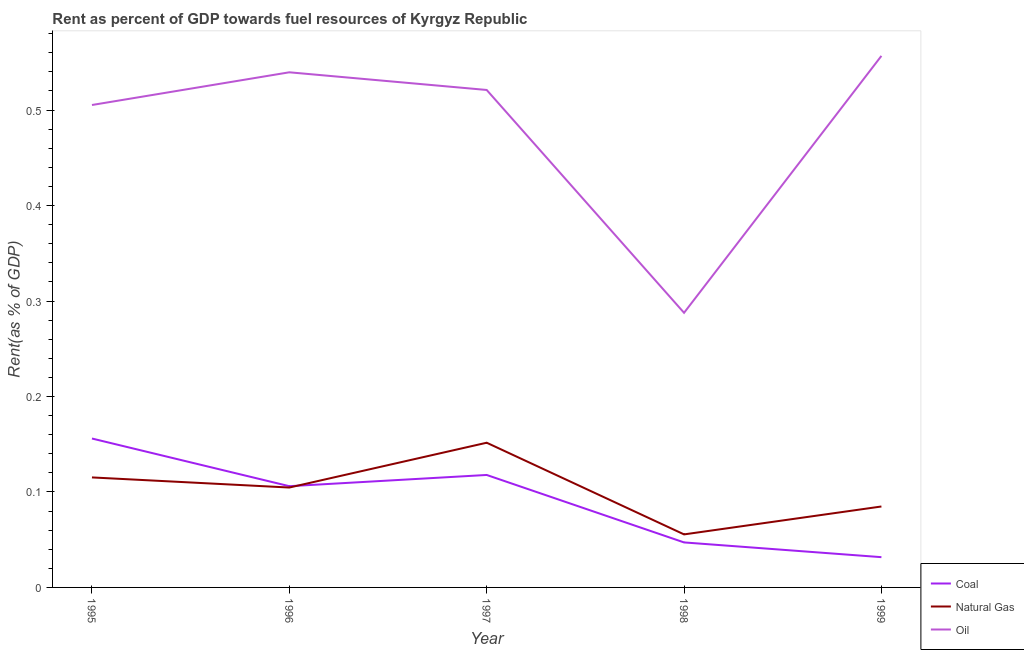How many different coloured lines are there?
Your answer should be compact. 3. What is the rent towards natural gas in 1995?
Your response must be concise. 0.12. Across all years, what is the maximum rent towards coal?
Your answer should be very brief. 0.16. Across all years, what is the minimum rent towards oil?
Keep it short and to the point. 0.29. In which year was the rent towards oil maximum?
Your answer should be very brief. 1999. What is the total rent towards natural gas in the graph?
Offer a very short reply. 0.51. What is the difference between the rent towards natural gas in 1997 and that in 1998?
Your response must be concise. 0.1. What is the difference between the rent towards oil in 1997 and the rent towards natural gas in 1999?
Provide a short and direct response. 0.44. What is the average rent towards oil per year?
Give a very brief answer. 0.48. In the year 1998, what is the difference between the rent towards coal and rent towards oil?
Keep it short and to the point. -0.24. What is the ratio of the rent towards natural gas in 1997 to that in 1999?
Give a very brief answer. 1.79. Is the rent towards coal in 1995 less than that in 1997?
Provide a succinct answer. No. Is the difference between the rent towards natural gas in 1995 and 1999 greater than the difference between the rent towards coal in 1995 and 1999?
Provide a succinct answer. No. What is the difference between the highest and the second highest rent towards natural gas?
Offer a very short reply. 0.04. What is the difference between the highest and the lowest rent towards natural gas?
Ensure brevity in your answer.  0.1. Is it the case that in every year, the sum of the rent towards coal and rent towards natural gas is greater than the rent towards oil?
Provide a succinct answer. No. Does the rent towards coal monotonically increase over the years?
Offer a very short reply. No. Is the rent towards natural gas strictly greater than the rent towards oil over the years?
Make the answer very short. No. How many lines are there?
Provide a succinct answer. 3. What is the difference between two consecutive major ticks on the Y-axis?
Your response must be concise. 0.1. Are the values on the major ticks of Y-axis written in scientific E-notation?
Your answer should be very brief. No. Does the graph contain any zero values?
Provide a short and direct response. No. Where does the legend appear in the graph?
Offer a very short reply. Bottom right. How many legend labels are there?
Make the answer very short. 3. How are the legend labels stacked?
Your answer should be very brief. Vertical. What is the title of the graph?
Provide a succinct answer. Rent as percent of GDP towards fuel resources of Kyrgyz Republic. Does "Self-employed" appear as one of the legend labels in the graph?
Keep it short and to the point. No. What is the label or title of the Y-axis?
Offer a terse response. Rent(as % of GDP). What is the Rent(as % of GDP) in Coal in 1995?
Keep it short and to the point. 0.16. What is the Rent(as % of GDP) of Natural Gas in 1995?
Ensure brevity in your answer.  0.12. What is the Rent(as % of GDP) of Oil in 1995?
Keep it short and to the point. 0.51. What is the Rent(as % of GDP) in Coal in 1996?
Provide a short and direct response. 0.11. What is the Rent(as % of GDP) in Natural Gas in 1996?
Your response must be concise. 0.1. What is the Rent(as % of GDP) of Oil in 1996?
Give a very brief answer. 0.54. What is the Rent(as % of GDP) of Coal in 1997?
Your answer should be compact. 0.12. What is the Rent(as % of GDP) of Natural Gas in 1997?
Your answer should be compact. 0.15. What is the Rent(as % of GDP) in Oil in 1997?
Offer a terse response. 0.52. What is the Rent(as % of GDP) in Coal in 1998?
Your answer should be very brief. 0.05. What is the Rent(as % of GDP) of Natural Gas in 1998?
Your response must be concise. 0.06. What is the Rent(as % of GDP) of Oil in 1998?
Your response must be concise. 0.29. What is the Rent(as % of GDP) in Coal in 1999?
Your answer should be very brief. 0.03. What is the Rent(as % of GDP) in Natural Gas in 1999?
Provide a short and direct response. 0.08. What is the Rent(as % of GDP) of Oil in 1999?
Provide a succinct answer. 0.56. Across all years, what is the maximum Rent(as % of GDP) in Coal?
Keep it short and to the point. 0.16. Across all years, what is the maximum Rent(as % of GDP) in Natural Gas?
Make the answer very short. 0.15. Across all years, what is the maximum Rent(as % of GDP) of Oil?
Your response must be concise. 0.56. Across all years, what is the minimum Rent(as % of GDP) in Coal?
Provide a short and direct response. 0.03. Across all years, what is the minimum Rent(as % of GDP) of Natural Gas?
Offer a very short reply. 0.06. Across all years, what is the minimum Rent(as % of GDP) in Oil?
Provide a succinct answer. 0.29. What is the total Rent(as % of GDP) in Coal in the graph?
Offer a terse response. 0.46. What is the total Rent(as % of GDP) in Natural Gas in the graph?
Offer a terse response. 0.51. What is the total Rent(as % of GDP) in Oil in the graph?
Your answer should be compact. 2.41. What is the difference between the Rent(as % of GDP) in Coal in 1995 and that in 1996?
Provide a succinct answer. 0.05. What is the difference between the Rent(as % of GDP) of Natural Gas in 1995 and that in 1996?
Ensure brevity in your answer.  0.01. What is the difference between the Rent(as % of GDP) in Oil in 1995 and that in 1996?
Offer a very short reply. -0.03. What is the difference between the Rent(as % of GDP) in Coal in 1995 and that in 1997?
Offer a very short reply. 0.04. What is the difference between the Rent(as % of GDP) in Natural Gas in 1995 and that in 1997?
Provide a short and direct response. -0.04. What is the difference between the Rent(as % of GDP) of Oil in 1995 and that in 1997?
Provide a short and direct response. -0.02. What is the difference between the Rent(as % of GDP) of Coal in 1995 and that in 1998?
Offer a terse response. 0.11. What is the difference between the Rent(as % of GDP) of Natural Gas in 1995 and that in 1998?
Ensure brevity in your answer.  0.06. What is the difference between the Rent(as % of GDP) in Oil in 1995 and that in 1998?
Offer a very short reply. 0.22. What is the difference between the Rent(as % of GDP) in Coal in 1995 and that in 1999?
Your answer should be compact. 0.12. What is the difference between the Rent(as % of GDP) in Natural Gas in 1995 and that in 1999?
Provide a succinct answer. 0.03. What is the difference between the Rent(as % of GDP) of Oil in 1995 and that in 1999?
Offer a very short reply. -0.05. What is the difference between the Rent(as % of GDP) of Coal in 1996 and that in 1997?
Offer a terse response. -0.01. What is the difference between the Rent(as % of GDP) in Natural Gas in 1996 and that in 1997?
Make the answer very short. -0.05. What is the difference between the Rent(as % of GDP) of Oil in 1996 and that in 1997?
Offer a very short reply. 0.02. What is the difference between the Rent(as % of GDP) in Coal in 1996 and that in 1998?
Offer a very short reply. 0.06. What is the difference between the Rent(as % of GDP) of Natural Gas in 1996 and that in 1998?
Your answer should be compact. 0.05. What is the difference between the Rent(as % of GDP) in Oil in 1996 and that in 1998?
Make the answer very short. 0.25. What is the difference between the Rent(as % of GDP) of Coal in 1996 and that in 1999?
Make the answer very short. 0.07. What is the difference between the Rent(as % of GDP) of Natural Gas in 1996 and that in 1999?
Your response must be concise. 0.02. What is the difference between the Rent(as % of GDP) in Oil in 1996 and that in 1999?
Make the answer very short. -0.02. What is the difference between the Rent(as % of GDP) of Coal in 1997 and that in 1998?
Your answer should be compact. 0.07. What is the difference between the Rent(as % of GDP) in Natural Gas in 1997 and that in 1998?
Provide a short and direct response. 0.1. What is the difference between the Rent(as % of GDP) in Oil in 1997 and that in 1998?
Your answer should be compact. 0.23. What is the difference between the Rent(as % of GDP) of Coal in 1997 and that in 1999?
Provide a succinct answer. 0.09. What is the difference between the Rent(as % of GDP) of Natural Gas in 1997 and that in 1999?
Your answer should be very brief. 0.07. What is the difference between the Rent(as % of GDP) of Oil in 1997 and that in 1999?
Your response must be concise. -0.04. What is the difference between the Rent(as % of GDP) in Coal in 1998 and that in 1999?
Offer a very short reply. 0.02. What is the difference between the Rent(as % of GDP) in Natural Gas in 1998 and that in 1999?
Make the answer very short. -0.03. What is the difference between the Rent(as % of GDP) in Oil in 1998 and that in 1999?
Offer a very short reply. -0.27. What is the difference between the Rent(as % of GDP) of Coal in 1995 and the Rent(as % of GDP) of Natural Gas in 1996?
Your response must be concise. 0.05. What is the difference between the Rent(as % of GDP) in Coal in 1995 and the Rent(as % of GDP) in Oil in 1996?
Provide a succinct answer. -0.38. What is the difference between the Rent(as % of GDP) of Natural Gas in 1995 and the Rent(as % of GDP) of Oil in 1996?
Your answer should be very brief. -0.42. What is the difference between the Rent(as % of GDP) in Coal in 1995 and the Rent(as % of GDP) in Natural Gas in 1997?
Provide a short and direct response. 0. What is the difference between the Rent(as % of GDP) in Coal in 1995 and the Rent(as % of GDP) in Oil in 1997?
Your response must be concise. -0.37. What is the difference between the Rent(as % of GDP) in Natural Gas in 1995 and the Rent(as % of GDP) in Oil in 1997?
Your answer should be very brief. -0.41. What is the difference between the Rent(as % of GDP) of Coal in 1995 and the Rent(as % of GDP) of Natural Gas in 1998?
Make the answer very short. 0.1. What is the difference between the Rent(as % of GDP) of Coal in 1995 and the Rent(as % of GDP) of Oil in 1998?
Provide a succinct answer. -0.13. What is the difference between the Rent(as % of GDP) in Natural Gas in 1995 and the Rent(as % of GDP) in Oil in 1998?
Ensure brevity in your answer.  -0.17. What is the difference between the Rent(as % of GDP) in Coal in 1995 and the Rent(as % of GDP) in Natural Gas in 1999?
Ensure brevity in your answer.  0.07. What is the difference between the Rent(as % of GDP) in Coal in 1995 and the Rent(as % of GDP) in Oil in 1999?
Provide a short and direct response. -0.4. What is the difference between the Rent(as % of GDP) of Natural Gas in 1995 and the Rent(as % of GDP) of Oil in 1999?
Your answer should be compact. -0.44. What is the difference between the Rent(as % of GDP) of Coal in 1996 and the Rent(as % of GDP) of Natural Gas in 1997?
Give a very brief answer. -0.05. What is the difference between the Rent(as % of GDP) of Coal in 1996 and the Rent(as % of GDP) of Oil in 1997?
Give a very brief answer. -0.41. What is the difference between the Rent(as % of GDP) of Natural Gas in 1996 and the Rent(as % of GDP) of Oil in 1997?
Offer a very short reply. -0.42. What is the difference between the Rent(as % of GDP) in Coal in 1996 and the Rent(as % of GDP) in Natural Gas in 1998?
Your answer should be very brief. 0.05. What is the difference between the Rent(as % of GDP) of Coal in 1996 and the Rent(as % of GDP) of Oil in 1998?
Ensure brevity in your answer.  -0.18. What is the difference between the Rent(as % of GDP) in Natural Gas in 1996 and the Rent(as % of GDP) in Oil in 1998?
Your answer should be very brief. -0.18. What is the difference between the Rent(as % of GDP) of Coal in 1996 and the Rent(as % of GDP) of Natural Gas in 1999?
Your answer should be compact. 0.02. What is the difference between the Rent(as % of GDP) in Coal in 1996 and the Rent(as % of GDP) in Oil in 1999?
Provide a short and direct response. -0.45. What is the difference between the Rent(as % of GDP) in Natural Gas in 1996 and the Rent(as % of GDP) in Oil in 1999?
Your response must be concise. -0.45. What is the difference between the Rent(as % of GDP) in Coal in 1997 and the Rent(as % of GDP) in Natural Gas in 1998?
Ensure brevity in your answer.  0.06. What is the difference between the Rent(as % of GDP) of Coal in 1997 and the Rent(as % of GDP) of Oil in 1998?
Keep it short and to the point. -0.17. What is the difference between the Rent(as % of GDP) of Natural Gas in 1997 and the Rent(as % of GDP) of Oil in 1998?
Make the answer very short. -0.14. What is the difference between the Rent(as % of GDP) of Coal in 1997 and the Rent(as % of GDP) of Natural Gas in 1999?
Provide a succinct answer. 0.03. What is the difference between the Rent(as % of GDP) of Coal in 1997 and the Rent(as % of GDP) of Oil in 1999?
Make the answer very short. -0.44. What is the difference between the Rent(as % of GDP) of Natural Gas in 1997 and the Rent(as % of GDP) of Oil in 1999?
Offer a terse response. -0.41. What is the difference between the Rent(as % of GDP) of Coal in 1998 and the Rent(as % of GDP) of Natural Gas in 1999?
Your answer should be compact. -0.04. What is the difference between the Rent(as % of GDP) of Coal in 1998 and the Rent(as % of GDP) of Oil in 1999?
Ensure brevity in your answer.  -0.51. What is the difference between the Rent(as % of GDP) in Natural Gas in 1998 and the Rent(as % of GDP) in Oil in 1999?
Your response must be concise. -0.5. What is the average Rent(as % of GDP) in Coal per year?
Your answer should be very brief. 0.09. What is the average Rent(as % of GDP) in Natural Gas per year?
Your response must be concise. 0.1. What is the average Rent(as % of GDP) of Oil per year?
Offer a very short reply. 0.48. In the year 1995, what is the difference between the Rent(as % of GDP) in Coal and Rent(as % of GDP) in Natural Gas?
Your answer should be compact. 0.04. In the year 1995, what is the difference between the Rent(as % of GDP) of Coal and Rent(as % of GDP) of Oil?
Provide a short and direct response. -0.35. In the year 1995, what is the difference between the Rent(as % of GDP) in Natural Gas and Rent(as % of GDP) in Oil?
Give a very brief answer. -0.39. In the year 1996, what is the difference between the Rent(as % of GDP) of Coal and Rent(as % of GDP) of Natural Gas?
Your response must be concise. 0. In the year 1996, what is the difference between the Rent(as % of GDP) in Coal and Rent(as % of GDP) in Oil?
Keep it short and to the point. -0.43. In the year 1996, what is the difference between the Rent(as % of GDP) in Natural Gas and Rent(as % of GDP) in Oil?
Your answer should be compact. -0.43. In the year 1997, what is the difference between the Rent(as % of GDP) of Coal and Rent(as % of GDP) of Natural Gas?
Provide a succinct answer. -0.03. In the year 1997, what is the difference between the Rent(as % of GDP) of Coal and Rent(as % of GDP) of Oil?
Give a very brief answer. -0.4. In the year 1997, what is the difference between the Rent(as % of GDP) of Natural Gas and Rent(as % of GDP) of Oil?
Offer a very short reply. -0.37. In the year 1998, what is the difference between the Rent(as % of GDP) in Coal and Rent(as % of GDP) in Natural Gas?
Provide a short and direct response. -0.01. In the year 1998, what is the difference between the Rent(as % of GDP) in Coal and Rent(as % of GDP) in Oil?
Keep it short and to the point. -0.24. In the year 1998, what is the difference between the Rent(as % of GDP) in Natural Gas and Rent(as % of GDP) in Oil?
Keep it short and to the point. -0.23. In the year 1999, what is the difference between the Rent(as % of GDP) in Coal and Rent(as % of GDP) in Natural Gas?
Provide a succinct answer. -0.05. In the year 1999, what is the difference between the Rent(as % of GDP) of Coal and Rent(as % of GDP) of Oil?
Provide a succinct answer. -0.53. In the year 1999, what is the difference between the Rent(as % of GDP) of Natural Gas and Rent(as % of GDP) of Oil?
Give a very brief answer. -0.47. What is the ratio of the Rent(as % of GDP) of Coal in 1995 to that in 1996?
Provide a succinct answer. 1.47. What is the ratio of the Rent(as % of GDP) in Natural Gas in 1995 to that in 1996?
Provide a succinct answer. 1.1. What is the ratio of the Rent(as % of GDP) of Oil in 1995 to that in 1996?
Make the answer very short. 0.94. What is the ratio of the Rent(as % of GDP) in Coal in 1995 to that in 1997?
Offer a terse response. 1.32. What is the ratio of the Rent(as % of GDP) in Natural Gas in 1995 to that in 1997?
Your answer should be very brief. 0.76. What is the ratio of the Rent(as % of GDP) of Oil in 1995 to that in 1997?
Offer a terse response. 0.97. What is the ratio of the Rent(as % of GDP) of Coal in 1995 to that in 1998?
Offer a terse response. 3.31. What is the ratio of the Rent(as % of GDP) of Natural Gas in 1995 to that in 1998?
Your answer should be very brief. 2.07. What is the ratio of the Rent(as % of GDP) of Oil in 1995 to that in 1998?
Keep it short and to the point. 1.76. What is the ratio of the Rent(as % of GDP) in Coal in 1995 to that in 1999?
Your response must be concise. 4.92. What is the ratio of the Rent(as % of GDP) in Natural Gas in 1995 to that in 1999?
Provide a short and direct response. 1.36. What is the ratio of the Rent(as % of GDP) of Oil in 1995 to that in 1999?
Your answer should be compact. 0.91. What is the ratio of the Rent(as % of GDP) in Coal in 1996 to that in 1997?
Provide a succinct answer. 0.9. What is the ratio of the Rent(as % of GDP) in Natural Gas in 1996 to that in 1997?
Offer a very short reply. 0.69. What is the ratio of the Rent(as % of GDP) of Oil in 1996 to that in 1997?
Ensure brevity in your answer.  1.04. What is the ratio of the Rent(as % of GDP) in Coal in 1996 to that in 1998?
Provide a short and direct response. 2.25. What is the ratio of the Rent(as % of GDP) of Natural Gas in 1996 to that in 1998?
Provide a succinct answer. 1.88. What is the ratio of the Rent(as % of GDP) of Oil in 1996 to that in 1998?
Offer a terse response. 1.88. What is the ratio of the Rent(as % of GDP) in Coal in 1996 to that in 1999?
Offer a very short reply. 3.35. What is the ratio of the Rent(as % of GDP) in Natural Gas in 1996 to that in 1999?
Your answer should be very brief. 1.23. What is the ratio of the Rent(as % of GDP) of Oil in 1996 to that in 1999?
Give a very brief answer. 0.97. What is the ratio of the Rent(as % of GDP) in Coal in 1997 to that in 1998?
Make the answer very short. 2.5. What is the ratio of the Rent(as % of GDP) of Natural Gas in 1997 to that in 1998?
Provide a short and direct response. 2.73. What is the ratio of the Rent(as % of GDP) of Oil in 1997 to that in 1998?
Give a very brief answer. 1.81. What is the ratio of the Rent(as % of GDP) in Coal in 1997 to that in 1999?
Your answer should be very brief. 3.72. What is the ratio of the Rent(as % of GDP) of Natural Gas in 1997 to that in 1999?
Give a very brief answer. 1.79. What is the ratio of the Rent(as % of GDP) of Oil in 1997 to that in 1999?
Your answer should be compact. 0.94. What is the ratio of the Rent(as % of GDP) of Coal in 1998 to that in 1999?
Keep it short and to the point. 1.49. What is the ratio of the Rent(as % of GDP) in Natural Gas in 1998 to that in 1999?
Offer a terse response. 0.66. What is the ratio of the Rent(as % of GDP) of Oil in 1998 to that in 1999?
Your answer should be compact. 0.52. What is the difference between the highest and the second highest Rent(as % of GDP) of Coal?
Offer a terse response. 0.04. What is the difference between the highest and the second highest Rent(as % of GDP) of Natural Gas?
Make the answer very short. 0.04. What is the difference between the highest and the second highest Rent(as % of GDP) in Oil?
Give a very brief answer. 0.02. What is the difference between the highest and the lowest Rent(as % of GDP) of Coal?
Give a very brief answer. 0.12. What is the difference between the highest and the lowest Rent(as % of GDP) of Natural Gas?
Your response must be concise. 0.1. What is the difference between the highest and the lowest Rent(as % of GDP) of Oil?
Offer a terse response. 0.27. 